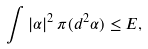<formula> <loc_0><loc_0><loc_500><loc_500>\int | \alpha | ^ { 2 } \, \pi ( d ^ { 2 } \alpha ) \leq E ,</formula> 